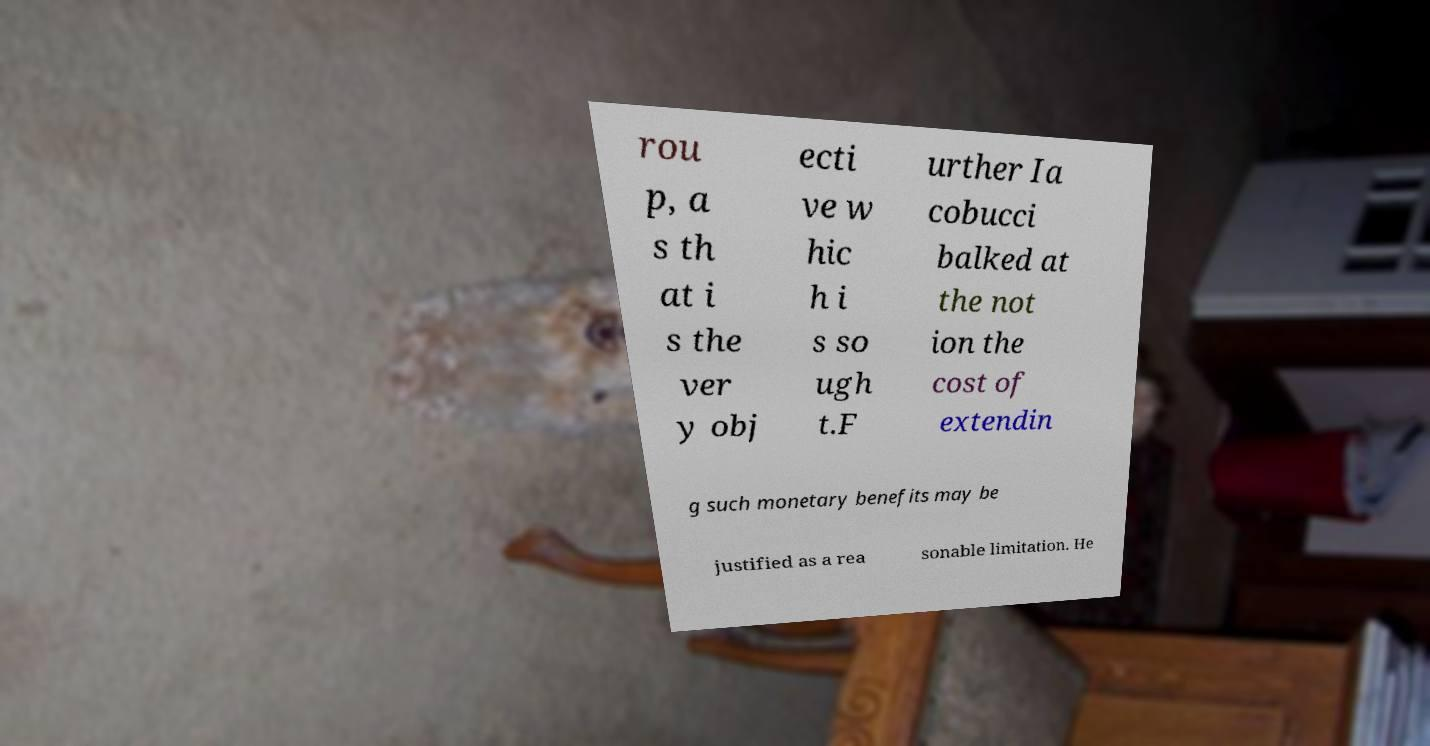I need the written content from this picture converted into text. Can you do that? rou p, a s th at i s the ver y obj ecti ve w hic h i s so ugh t.F urther Ia cobucci balked at the not ion the cost of extendin g such monetary benefits may be justified as a rea sonable limitation. He 